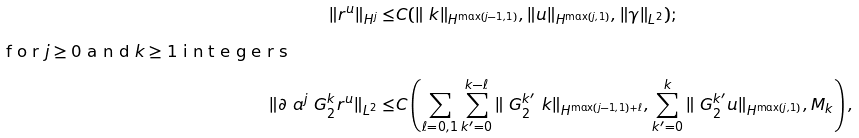<formula> <loc_0><loc_0><loc_500><loc_500>\| r ^ { u } \| _ { H ^ { j } } \leq & C ( \| \ k \| _ { H ^ { \max ( j - 1 , 1 ) } } , \| u \| _ { H ^ { \max ( j , 1 ) } } , \| \gamma \| _ { L ^ { 2 } } ) ; \intertext { f o r $ j \geq 0 $ a n d $ k \geq 1 $ i n t e g e r s } \| \partial _ { \ } a ^ { j } \ G _ { 2 } ^ { k } r ^ { u } \| _ { L ^ { 2 } } \leq & C \left ( \sum _ { \ell = 0 , 1 } \sum _ { k ^ { \prime } = 0 } ^ { k - \ell } \| \ G _ { 2 } ^ { k ^ { \prime } } \ k \| _ { H ^ { \max ( j - 1 , 1 ) + \ell } } , \sum _ { k ^ { \prime } = 0 } ^ { k } \| \ G _ { 2 } ^ { k ^ { \prime } } u \| _ { H ^ { \max ( j , 1 ) } } , M _ { k } \right ) ,</formula> 